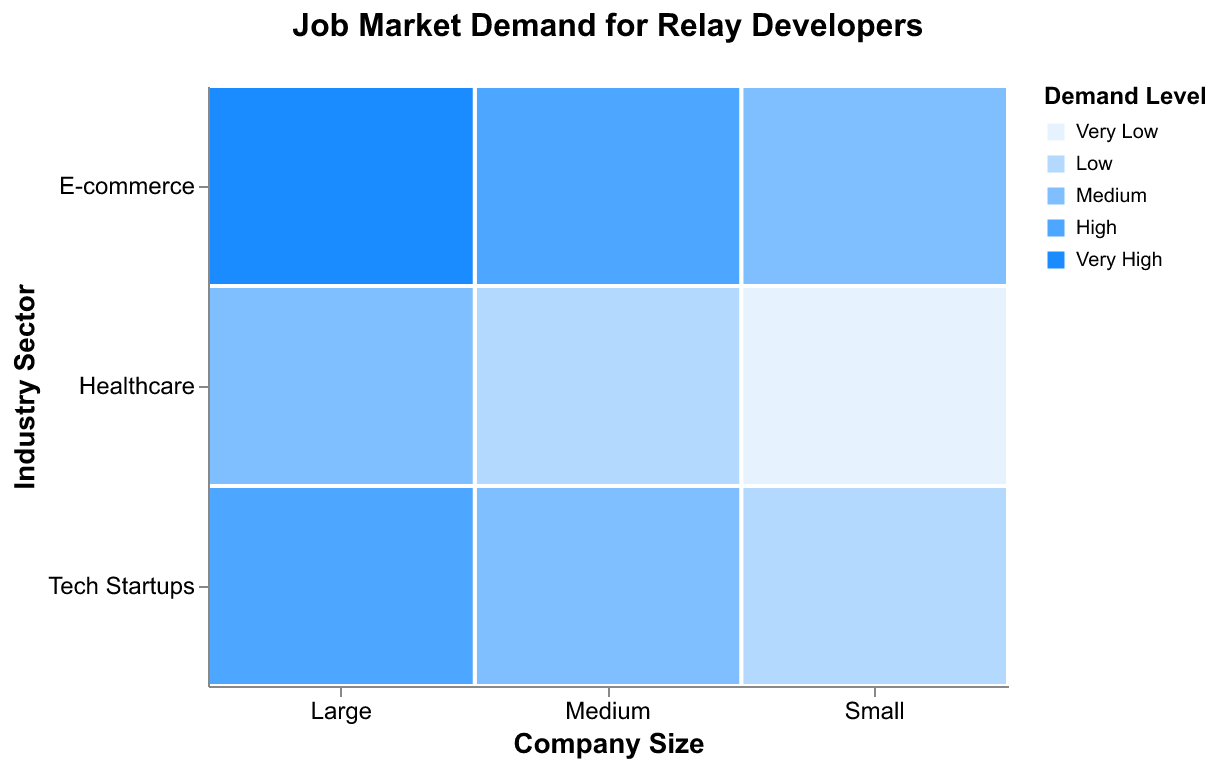What is the title of the figure? The title is usually displayed at the top of the figure. By reading it, we can see it says "Job Market Demand for Relay Developers."
Answer: Job Market Demand for Relay Developers Which company size has the highest demand level in the E-commerce industry? Look at the company size under the "E-commerce" row. The rectangle with the darkest blue shade represents the highest demand level. For E-commerce, the darkest shade belongs to the large company size.
Answer: Large How many different demand levels are represented in the plot? Refer to the legend on the plot, which shows the different colors indicating the demand levels. Count the unique demand levels listed: Very Low, Low, Medium, High, Very High.
Answer: 5 Which industry sector has the lowest demand level for small companies? Look at the small column in the plot and find the lightest color (representing Very Low) in this section. The industry sector corresponding to this color is Healthcare.
Answer: Healthcare In the Healthcare sector, what is the difference in demand level between small companies and medium companies? For Healthcare, check the demand level colors for small companies (Very Low) and medium companies (Low). The difference in the ordinal scale is one level.
Answer: One level Which combination of company size and industry sector has the highest overall demand level? Identify the darkest blue rectangle across the entire plot, which represents the highest demand level (Very High). This rectangle is found at the intersection of Large company size and E-commerce industry.
Answer: Large, E-commerce What is the common demand level for Tech Startups in both medium and large company sizes? Look within the Tech Startups row for medium and large columns. Both rectangles should have the same color representing the demand level. They both share the "High" demand level.
Answer: High How does the demand for Relay developers in the Tech Startups industry compare between small and large companies? Check the color representing demand in Tech Startups for small and large companies. Small shows "Low" (light blue) while large shows "High" (dark blue). There is an increase from Low to High.
Answer: Increase from Low to High Between which company sizes in the Healthcare sector is the demand level difference the greatest? Check colors associated with Healthcare for all company sizes. The range from Very Low (small) to Medium (large) reveals the greatest difference, spanning two levels (Very Low to Low to Medium).
Answer: Small and Large 